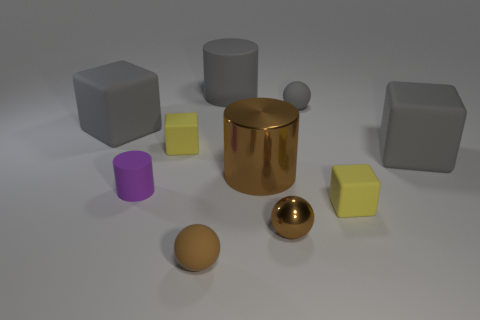Subtract all brown spheres. How many gray cubes are left? 2 Subtract all matte cylinders. How many cylinders are left? 1 Subtract 1 balls. How many balls are left? 2 Subtract all green blocks. Subtract all purple cylinders. How many blocks are left? 4 Subtract all blocks. How many objects are left? 6 Subtract 0 blue spheres. How many objects are left? 10 Subtract all small gray objects. Subtract all big cylinders. How many objects are left? 7 Add 5 yellow matte blocks. How many yellow matte blocks are left? 7 Add 7 big metal things. How many big metal things exist? 8 